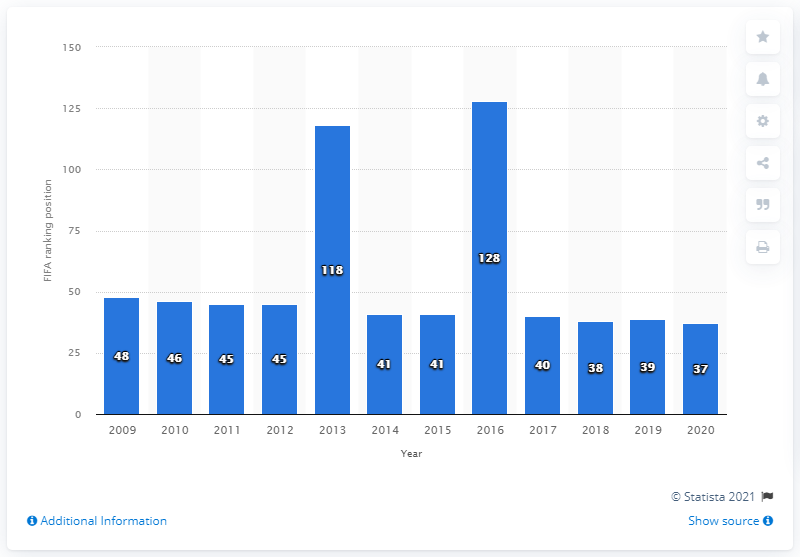Mention a couple of crucial points in this snapshot. In 2016, the Chilean women's soccer team experienced its lowest ranking worldwide. 